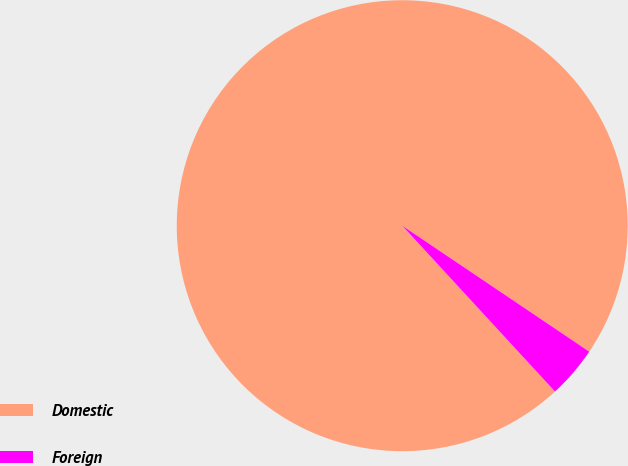Convert chart to OTSL. <chart><loc_0><loc_0><loc_500><loc_500><pie_chart><fcel>Domestic<fcel>Foreign<nl><fcel>96.28%<fcel>3.72%<nl></chart> 